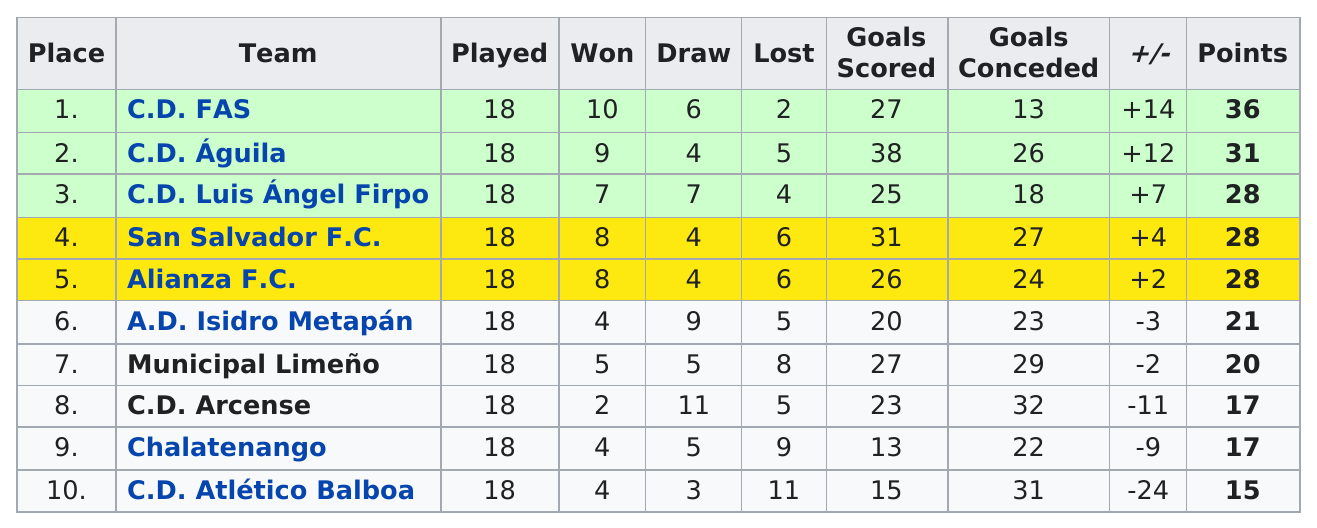Draw attention to some important aspects in this diagram. Two teams, San Salvador F.C. and Alianza F.C., ended the season with the same record of wins, losses, and draws. Allianza FC received 28 points in the competition. The difference in points between C.D. Aguila and Chalatenango is 14. C.D. FAS was the top team in the standings of the Apertura 2003 tournament. The team that scored the most points is C.D. FAS. 